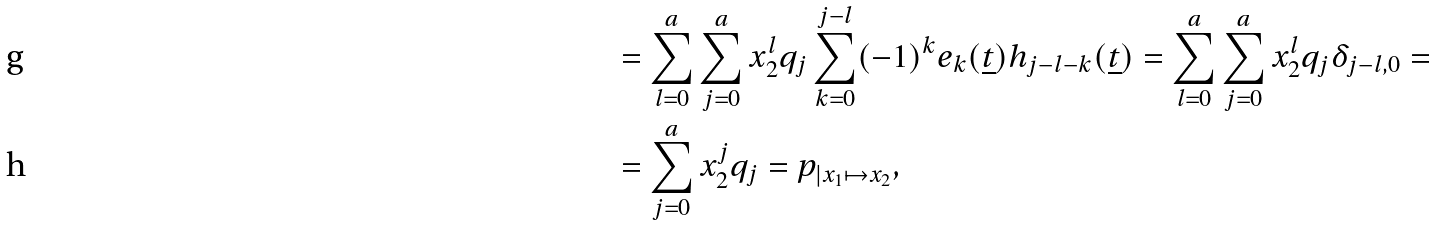<formula> <loc_0><loc_0><loc_500><loc_500>& = \sum _ { l = 0 } ^ { a } \sum _ { j = 0 } ^ { a } x _ { 2 } ^ { l } q _ { j } \sum _ { k = 0 } ^ { j - l } ( - 1 ) ^ { k } e _ { k } ( \underline { t } ) h _ { j - l - k } ( \underline { t } ) = \sum _ { l = 0 } ^ { a } \sum _ { j = 0 } ^ { a } x _ { 2 } ^ { l } q _ { j } \delta _ { j - l , 0 } = \\ & = \sum _ { j = 0 } ^ { a } x _ { 2 } ^ { j } q _ { j } = p _ { | x _ { 1 } \mapsto x _ { 2 } } ,</formula> 